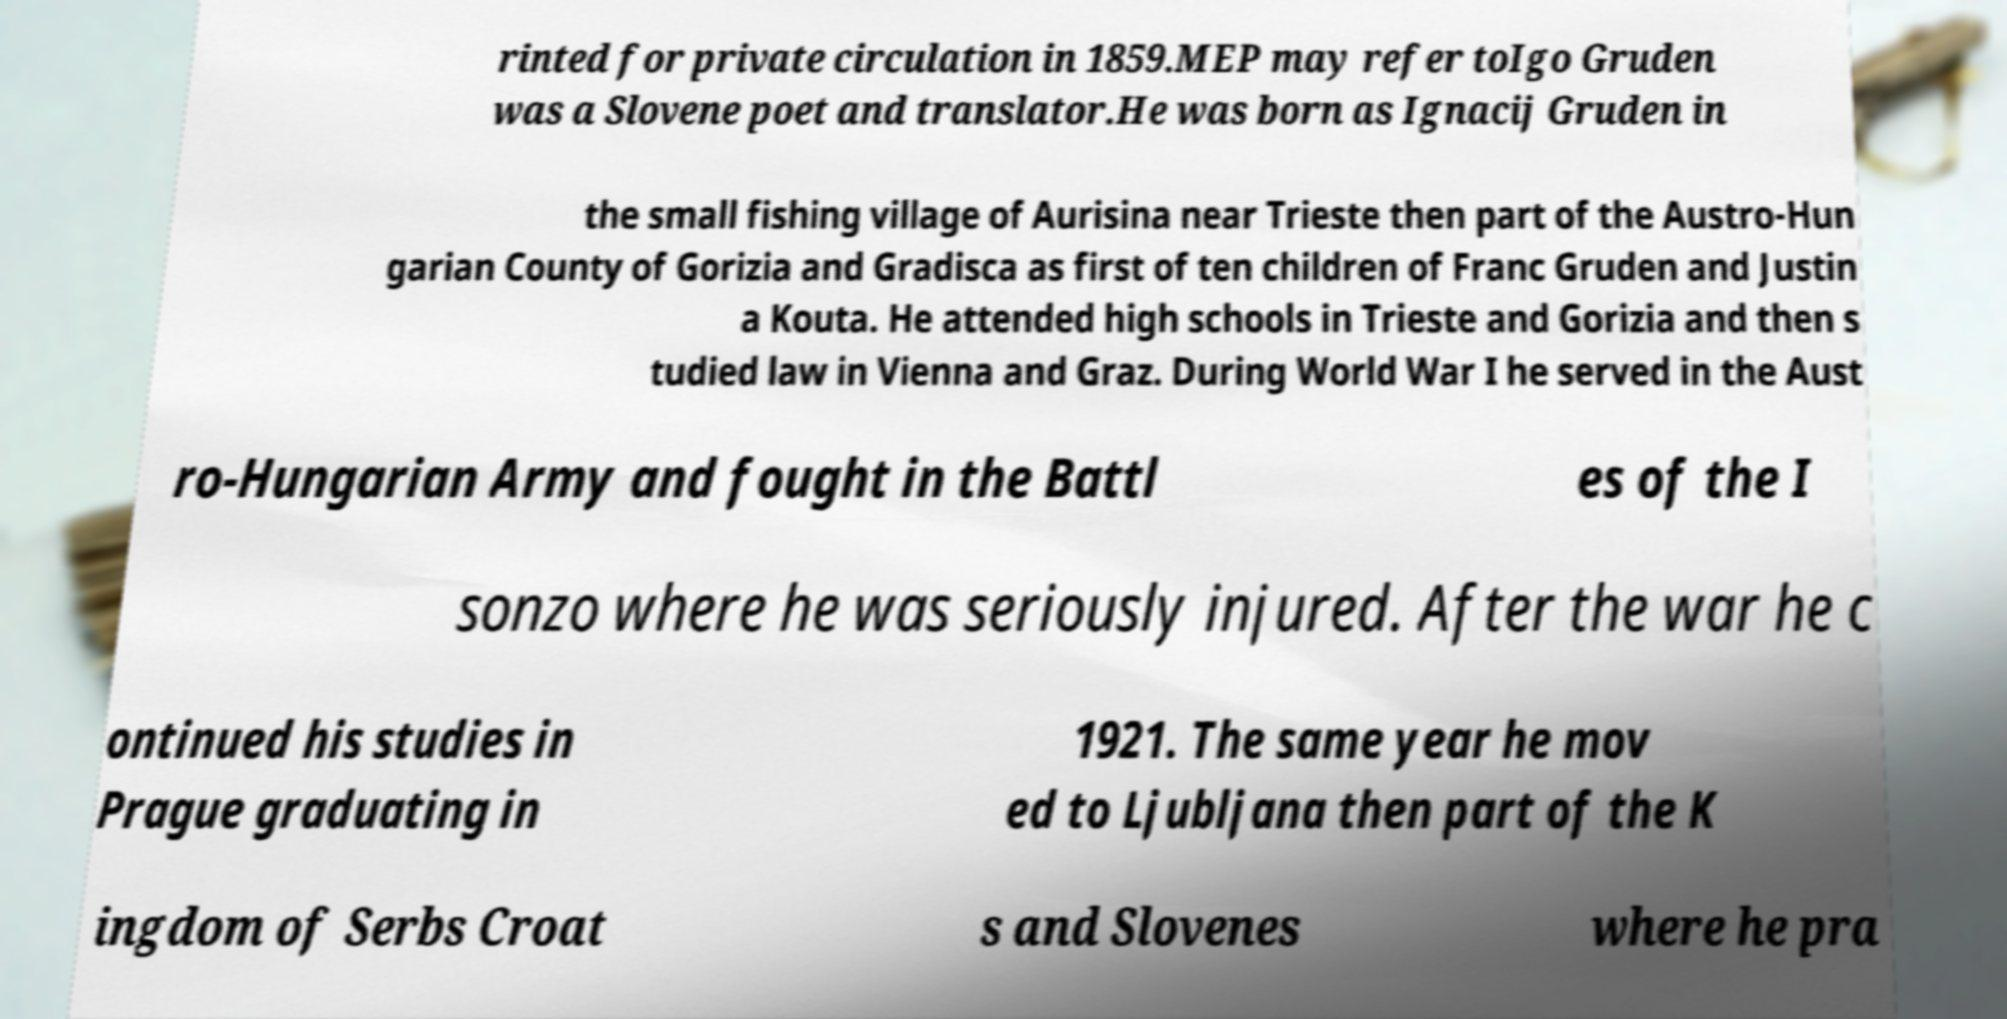For documentation purposes, I need the text within this image transcribed. Could you provide that? rinted for private circulation in 1859.MEP may refer toIgo Gruden was a Slovene poet and translator.He was born as Ignacij Gruden in the small fishing village of Aurisina near Trieste then part of the Austro-Hun garian County of Gorizia and Gradisca as first of ten children of Franc Gruden and Justin a Kouta. He attended high schools in Trieste and Gorizia and then s tudied law in Vienna and Graz. During World War I he served in the Aust ro-Hungarian Army and fought in the Battl es of the I sonzo where he was seriously injured. After the war he c ontinued his studies in Prague graduating in 1921. The same year he mov ed to Ljubljana then part of the K ingdom of Serbs Croat s and Slovenes where he pra 